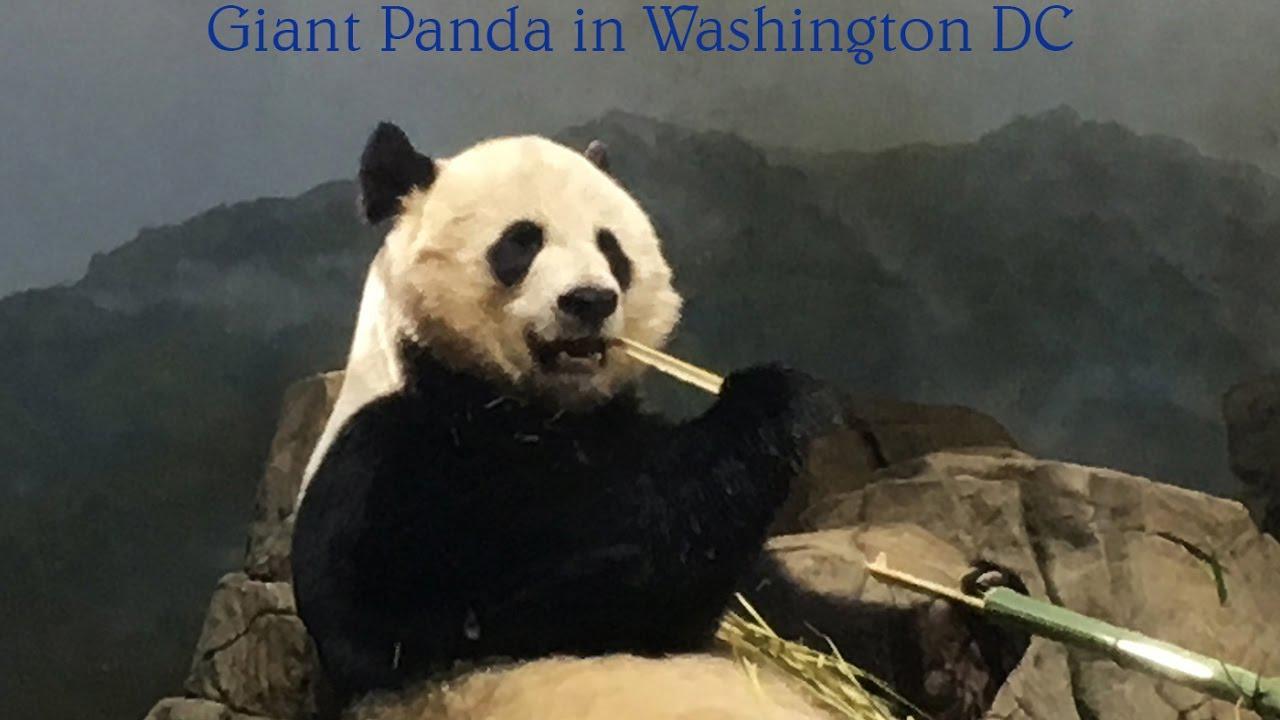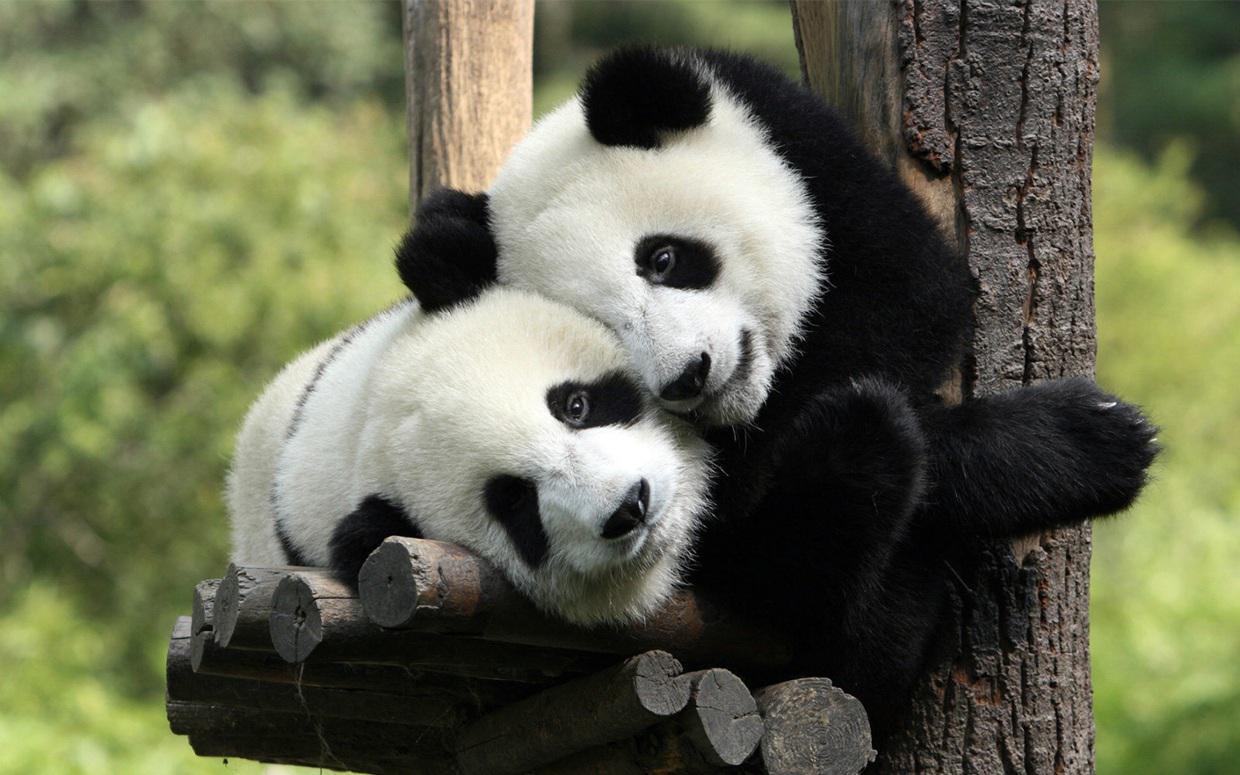The first image is the image on the left, the second image is the image on the right. Considering the images on both sides, is "There are three pandas" valid? Answer yes or no. Yes. 